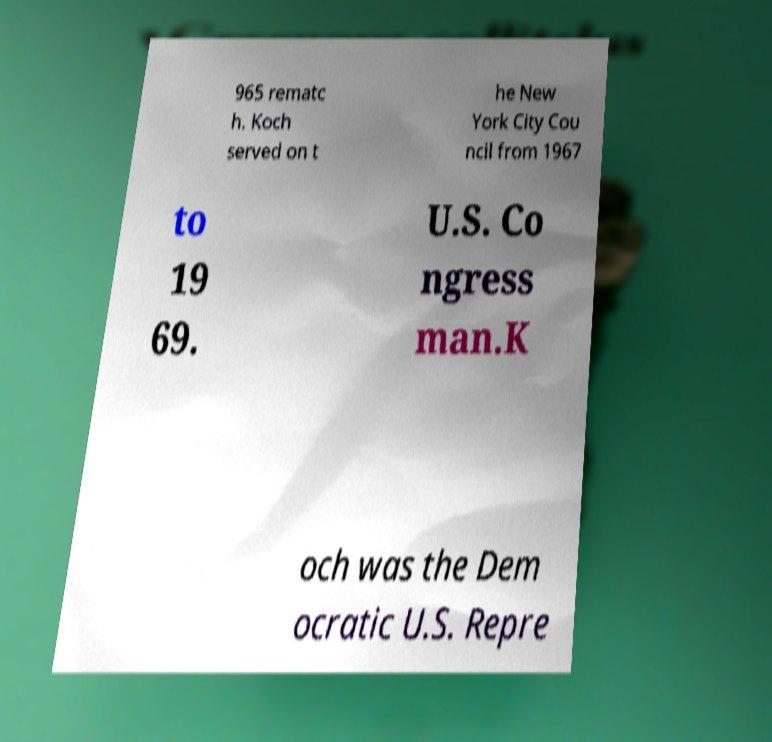For documentation purposes, I need the text within this image transcribed. Could you provide that? 965 rematc h. Koch served on t he New York City Cou ncil from 1967 to 19 69. U.S. Co ngress man.K och was the Dem ocratic U.S. Repre 